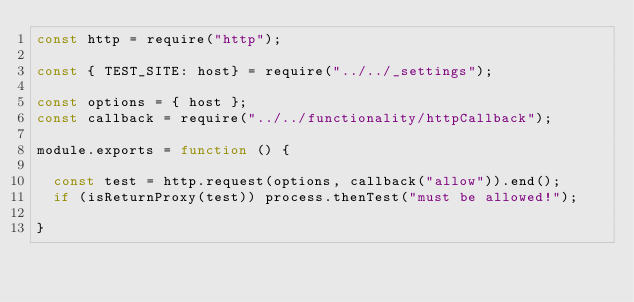Convert code to text. <code><loc_0><loc_0><loc_500><loc_500><_JavaScript_>const http = require("http");

const { TEST_SITE: host} = require("../../_settings");

const options = { host };
const callback = require("../../functionality/httpCallback");

module.exports = function () {

	const test = http.request(options, callback("allow")).end();
	if (isReturnProxy(test)) process.thenTest("must be allowed!");

}</code> 